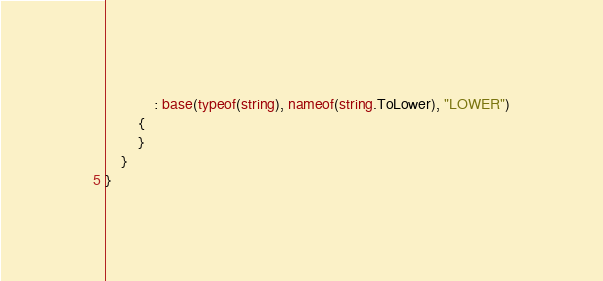Convert code to text. <code><loc_0><loc_0><loc_500><loc_500><_C#_>            : base(typeof(string), nameof(string.ToLower), "LOWER")
        {
        }
    }
}
</code> 